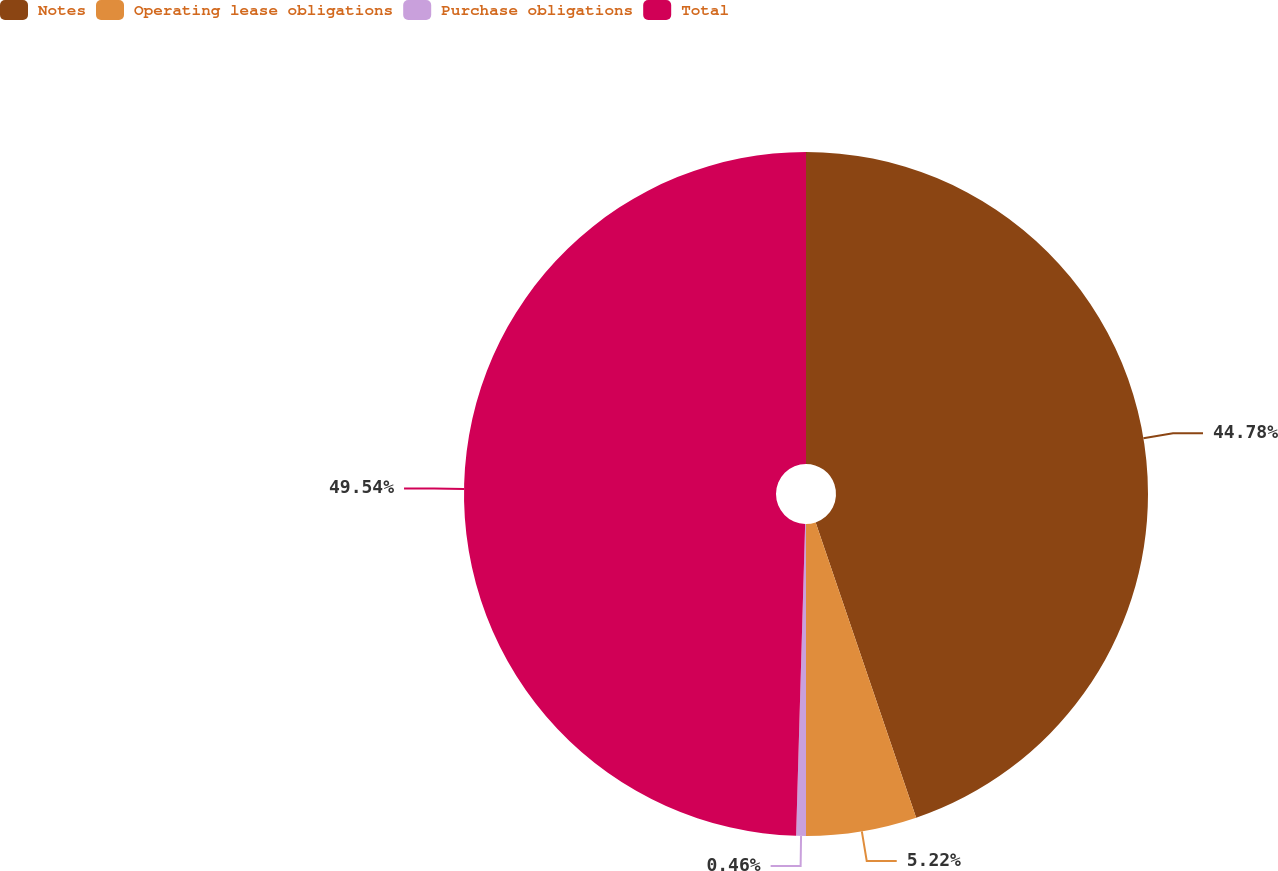<chart> <loc_0><loc_0><loc_500><loc_500><pie_chart><fcel>Notes<fcel>Operating lease obligations<fcel>Purchase obligations<fcel>Total<nl><fcel>44.78%<fcel>5.22%<fcel>0.46%<fcel>49.54%<nl></chart> 